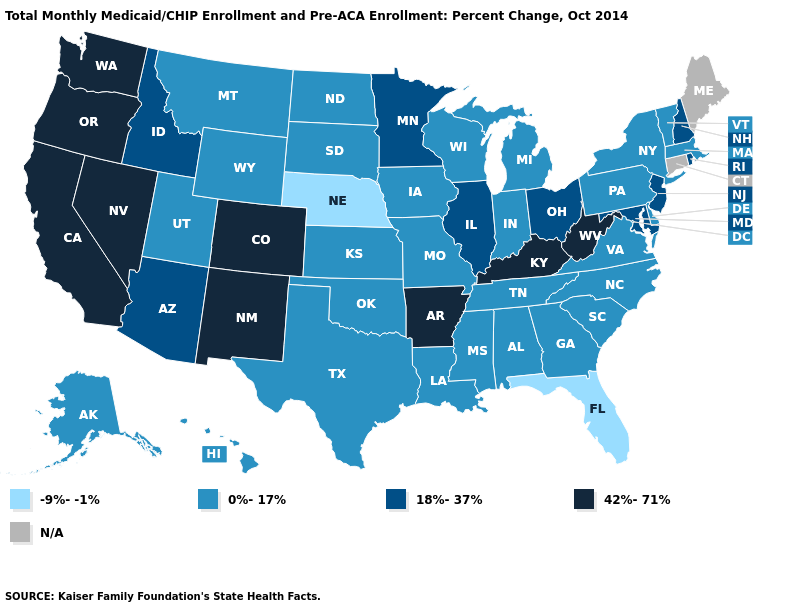What is the value of Montana?
Write a very short answer. 0%-17%. Name the states that have a value in the range 42%-71%?
Quick response, please. Arkansas, California, Colorado, Kentucky, Nevada, New Mexico, Oregon, Washington, West Virginia. Which states hav the highest value in the Northeast?
Be succinct. New Hampshire, New Jersey, Rhode Island. Which states hav the highest value in the Northeast?
Keep it brief. New Hampshire, New Jersey, Rhode Island. What is the lowest value in states that border Wisconsin?
Answer briefly. 0%-17%. What is the value of Massachusetts?
Keep it brief. 0%-17%. Which states have the highest value in the USA?
Quick response, please. Arkansas, California, Colorado, Kentucky, Nevada, New Mexico, Oregon, Washington, West Virginia. Name the states that have a value in the range 0%-17%?
Keep it brief. Alabama, Alaska, Delaware, Georgia, Hawaii, Indiana, Iowa, Kansas, Louisiana, Massachusetts, Michigan, Mississippi, Missouri, Montana, New York, North Carolina, North Dakota, Oklahoma, Pennsylvania, South Carolina, South Dakota, Tennessee, Texas, Utah, Vermont, Virginia, Wisconsin, Wyoming. Does Vermont have the lowest value in the Northeast?
Write a very short answer. Yes. Which states hav the highest value in the South?
Short answer required. Arkansas, Kentucky, West Virginia. Among the states that border Idaho , which have the lowest value?
Answer briefly. Montana, Utah, Wyoming. Does New Jersey have the lowest value in the Northeast?
Write a very short answer. No. Does Virginia have the lowest value in the USA?
Give a very brief answer. No. 